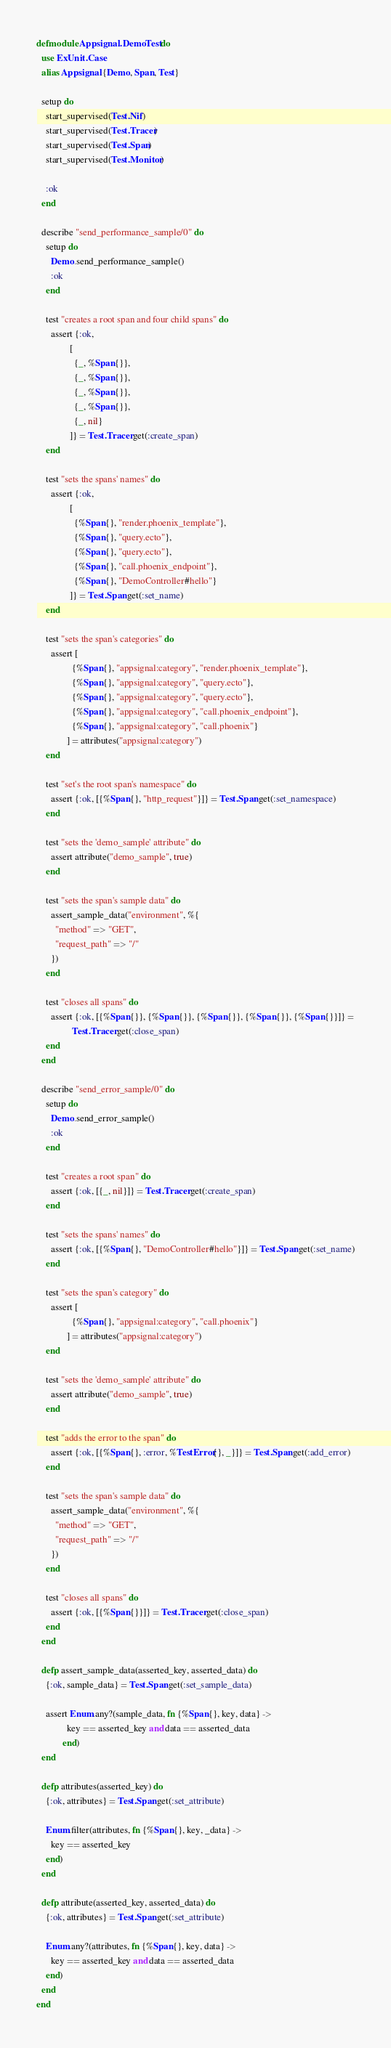Convert code to text. <code><loc_0><loc_0><loc_500><loc_500><_Elixir_>defmodule Appsignal.DemoTest do
  use ExUnit.Case
  alias Appsignal.{Demo, Span, Test}

  setup do
    start_supervised(Test.Nif)
    start_supervised(Test.Tracer)
    start_supervised(Test.Span)
    start_supervised(Test.Monitor)

    :ok
  end

  describe "send_performance_sample/0" do
    setup do
      Demo.send_performance_sample()
      :ok
    end

    test "creates a root span and four child spans" do
      assert {:ok,
              [
                {_, %Span{}},
                {_, %Span{}},
                {_, %Span{}},
                {_, %Span{}},
                {_, nil}
              ]} = Test.Tracer.get(:create_span)
    end

    test "sets the spans' names" do
      assert {:ok,
              [
                {%Span{}, "render.phoenix_template"},
                {%Span{}, "query.ecto"},
                {%Span{}, "query.ecto"},
                {%Span{}, "call.phoenix_endpoint"},
                {%Span{}, "DemoController#hello"}
              ]} = Test.Span.get(:set_name)
    end

    test "sets the span's categories" do
      assert [
               {%Span{}, "appsignal:category", "render.phoenix_template"},
               {%Span{}, "appsignal:category", "query.ecto"},
               {%Span{}, "appsignal:category", "query.ecto"},
               {%Span{}, "appsignal:category", "call.phoenix_endpoint"},
               {%Span{}, "appsignal:category", "call.phoenix"}
             ] = attributes("appsignal:category")
    end

    test "set's the root span's namespace" do
      assert {:ok, [{%Span{}, "http_request"}]} = Test.Span.get(:set_namespace)
    end

    test "sets the 'demo_sample' attribute" do
      assert attribute("demo_sample", true)
    end

    test "sets the span's sample data" do
      assert_sample_data("environment", %{
        "method" => "GET",
        "request_path" => "/"
      })
    end

    test "closes all spans" do
      assert {:ok, [{%Span{}}, {%Span{}}, {%Span{}}, {%Span{}}, {%Span{}}]} =
               Test.Tracer.get(:close_span)
    end
  end

  describe "send_error_sample/0" do
    setup do
      Demo.send_error_sample()
      :ok
    end

    test "creates a root span" do
      assert {:ok, [{_, nil}]} = Test.Tracer.get(:create_span)
    end

    test "sets the spans' names" do
      assert {:ok, [{%Span{}, "DemoController#hello"}]} = Test.Span.get(:set_name)
    end

    test "sets the span's category" do
      assert [
               {%Span{}, "appsignal:category", "call.phoenix"}
             ] = attributes("appsignal:category")
    end

    test "sets the 'demo_sample' attribute" do
      assert attribute("demo_sample", true)
    end

    test "adds the error to the span" do
      assert {:ok, [{%Span{}, :error, %TestError{}, _}]} = Test.Span.get(:add_error)
    end

    test "sets the span's sample data" do
      assert_sample_data("environment", %{
        "method" => "GET",
        "request_path" => "/"
      })
    end

    test "closes all spans" do
      assert {:ok, [{%Span{}}]} = Test.Tracer.get(:close_span)
    end
  end

  defp assert_sample_data(asserted_key, asserted_data) do
    {:ok, sample_data} = Test.Span.get(:set_sample_data)

    assert Enum.any?(sample_data, fn {%Span{}, key, data} ->
             key == asserted_key and data == asserted_data
           end)
  end

  defp attributes(asserted_key) do
    {:ok, attributes} = Test.Span.get(:set_attribute)

    Enum.filter(attributes, fn {%Span{}, key, _data} ->
      key == asserted_key
    end)
  end

  defp attribute(asserted_key, asserted_data) do
    {:ok, attributes} = Test.Span.get(:set_attribute)

    Enum.any?(attributes, fn {%Span{}, key, data} ->
      key == asserted_key and data == asserted_data
    end)
  end
end
</code> 